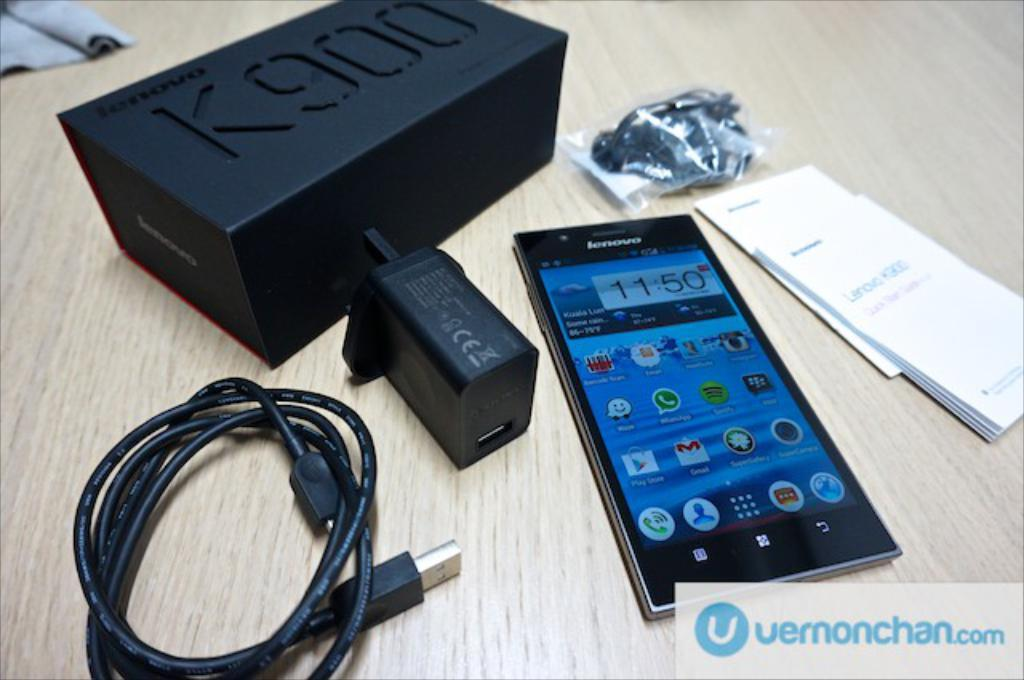What electronic device is present in the image? There is a cell phone in the image. What is used to charge the cell phone? There is a charger in the image. What type of cable is present in the image? There is a USB cable in the image. What is the container-like object in the image? There is a box in the image. What type of paper items are present in the image? There are papers in the image. What type of audio accessory is present in the image? There are earphones in the image. Where are all these objects located? All these objects are on a table. Can you see any cobwebs in the image? There is no mention of cobwebs in the image, so we cannot determine if they are present or not. 